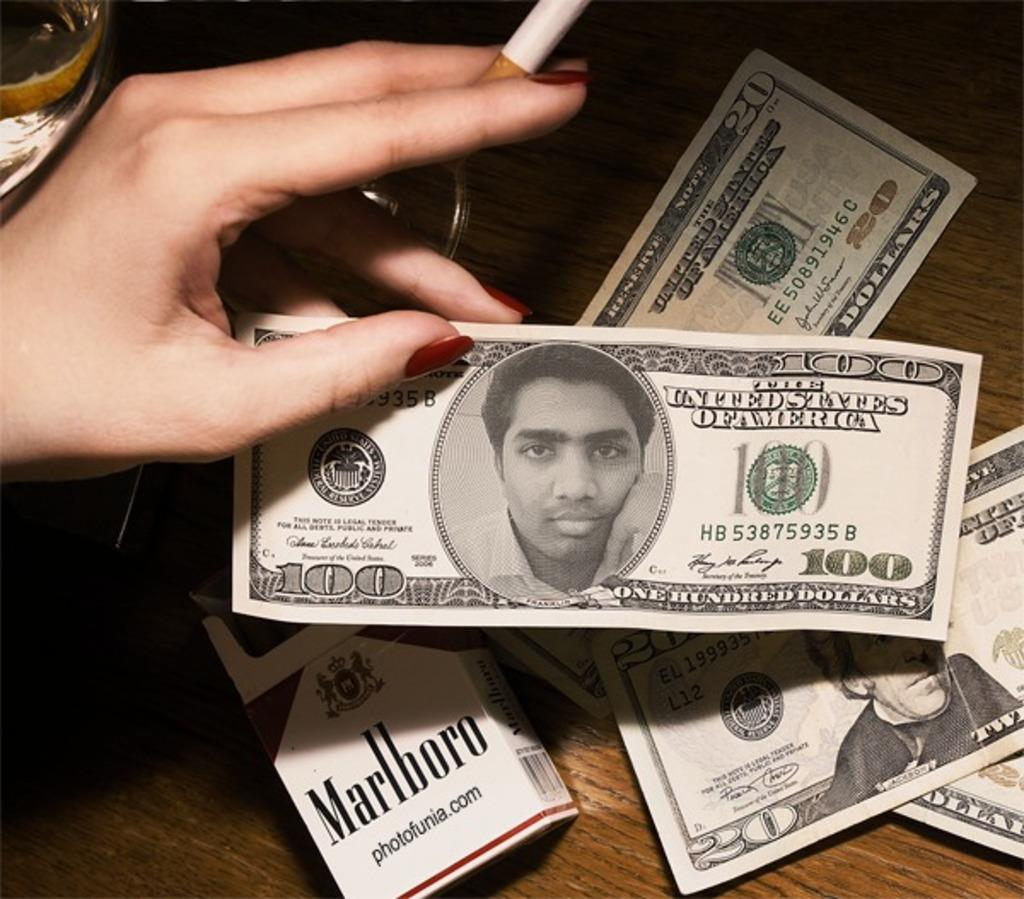<image>
Relay a brief, clear account of the picture shown. Box of Marlboro cigarettes and three twenty dollar bills plus a one hundred bill. 